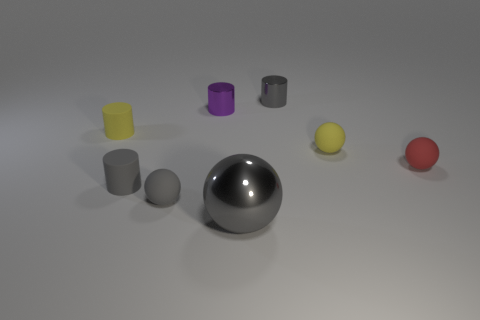What size is the metal cylinder that is the same color as the large metallic thing?
Give a very brief answer. Small. What number of metal objects are behind the gray shiny sphere and in front of the small yellow cylinder?
Keep it short and to the point. 0. What is the material of the tiny gray cylinder that is behind the red sphere?
Provide a succinct answer. Metal. What number of cylinders are the same color as the big sphere?
Your response must be concise. 2. What is the size of the red sphere that is the same material as the yellow cylinder?
Your response must be concise. Small. How many things are either big blue blocks or small yellow rubber objects?
Your answer should be compact. 2. The ball that is behind the red object is what color?
Your response must be concise. Yellow. There is a red rubber object that is the same shape as the big gray shiny object; what is its size?
Provide a short and direct response. Small. How many objects are tiny metallic things that are on the right side of the large sphere or gray objects that are behind the tiny yellow rubber ball?
Offer a terse response. 1. How big is the gray object that is both in front of the purple cylinder and right of the purple shiny cylinder?
Your answer should be very brief. Large. 